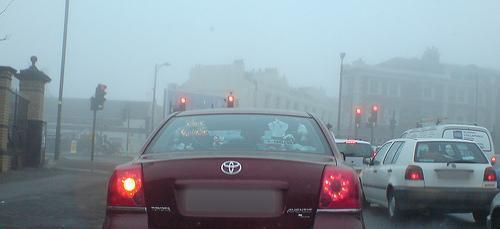How many signals are there?
Give a very brief answer. 5. 